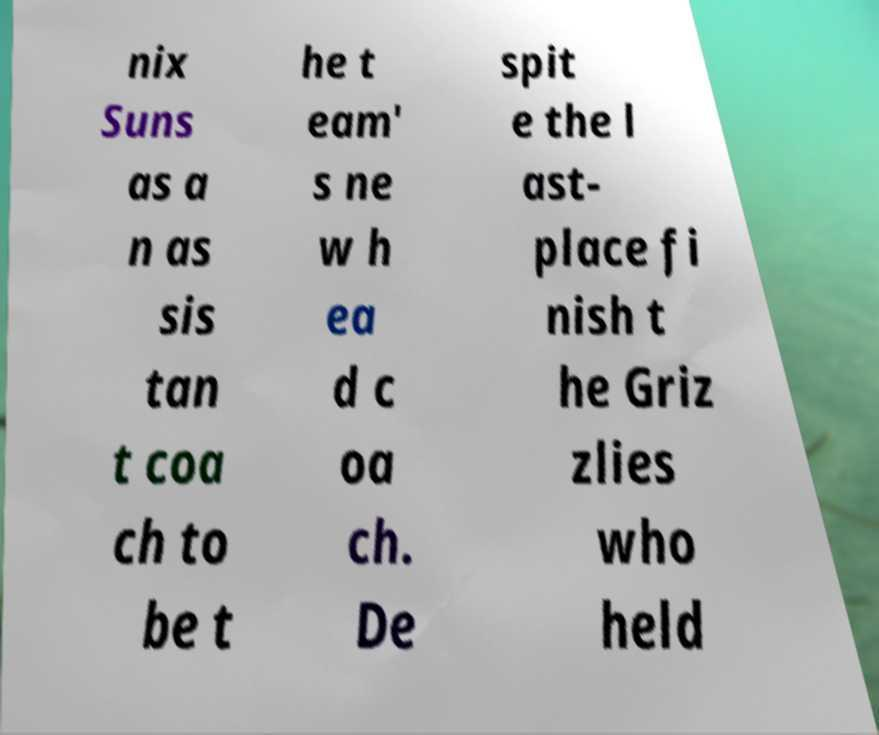I need the written content from this picture converted into text. Can you do that? nix Suns as a n as sis tan t coa ch to be t he t eam' s ne w h ea d c oa ch. De spit e the l ast- place fi nish t he Griz zlies who held 